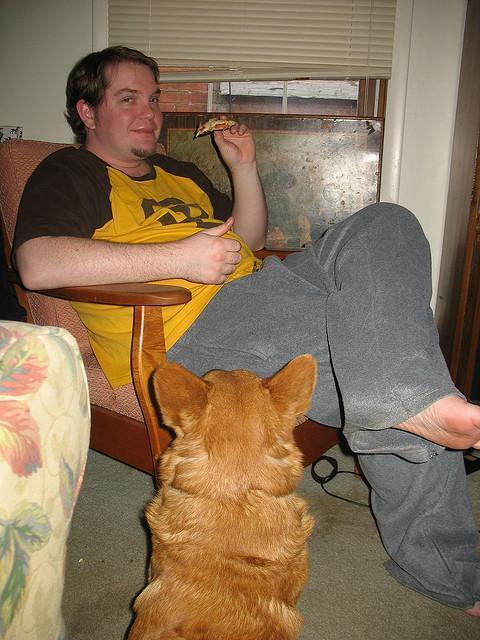How many chairs can you see?
Give a very brief answer. 1. 